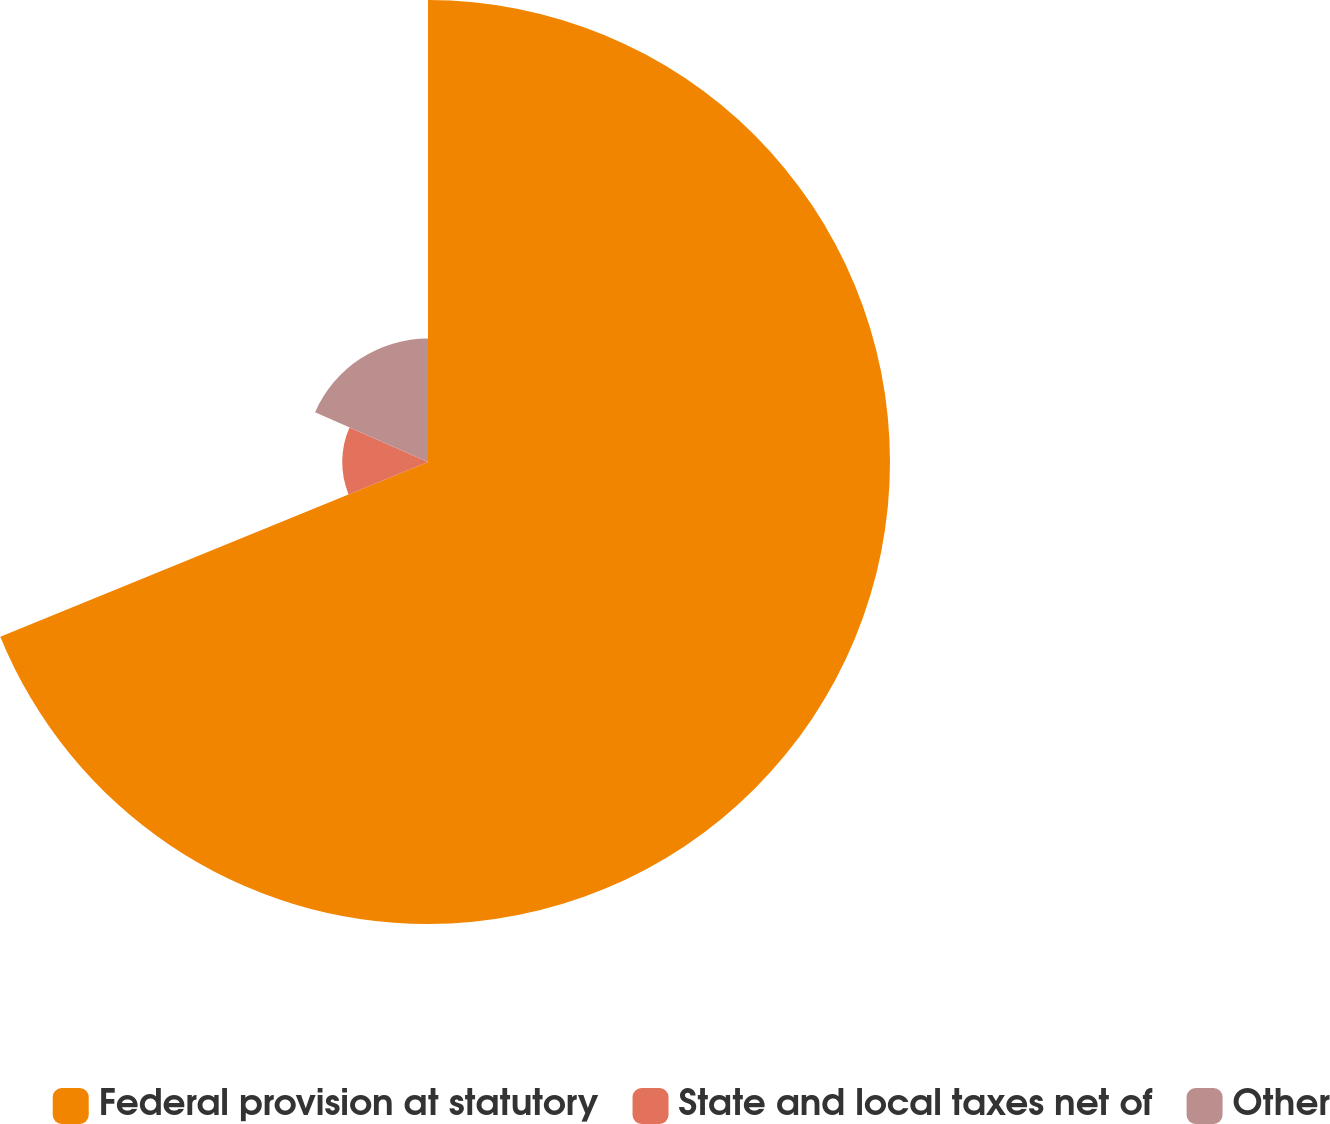Convert chart to OTSL. <chart><loc_0><loc_0><loc_500><loc_500><pie_chart><fcel>Federal provision at statutory<fcel>State and local taxes net of<fcel>Other<nl><fcel>68.83%<fcel>12.78%<fcel>18.39%<nl></chart> 